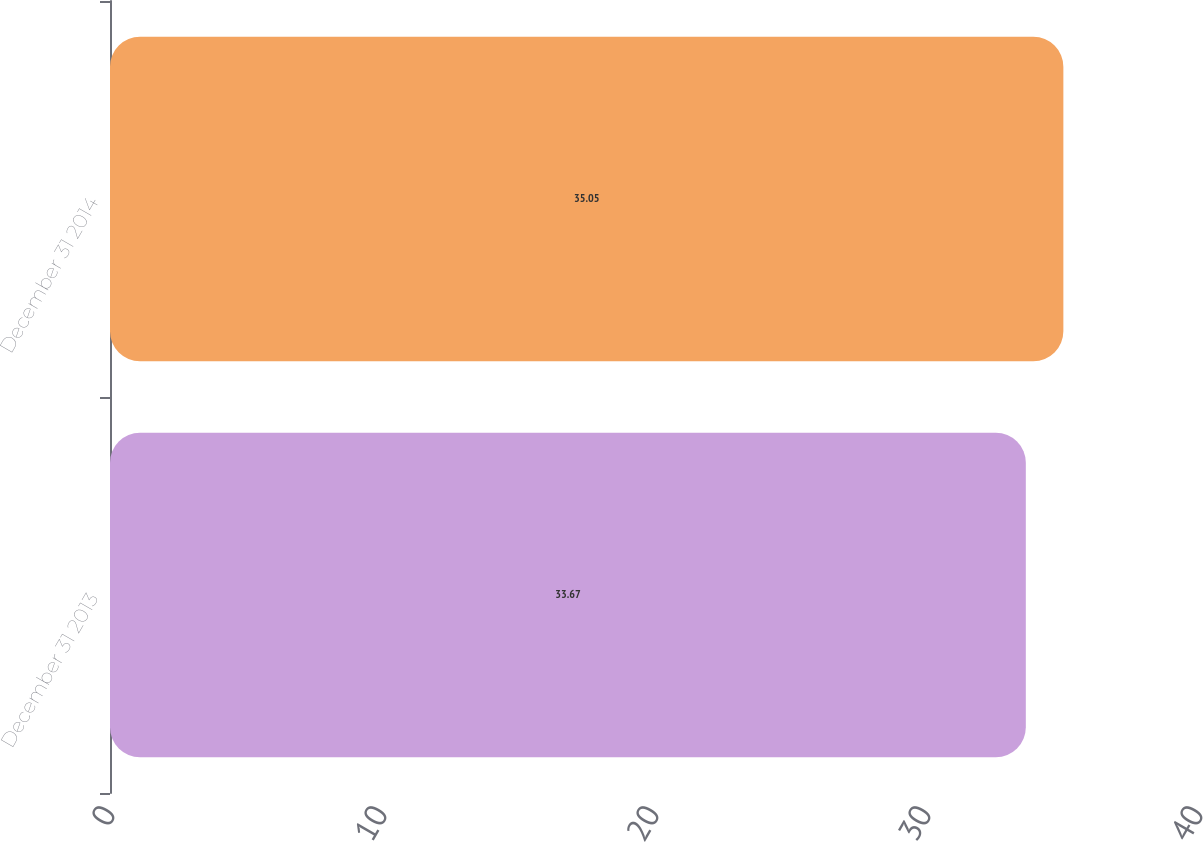<chart> <loc_0><loc_0><loc_500><loc_500><bar_chart><fcel>December 31 2013<fcel>December 31 2014<nl><fcel>33.67<fcel>35.05<nl></chart> 